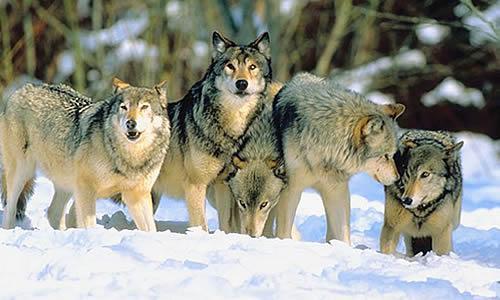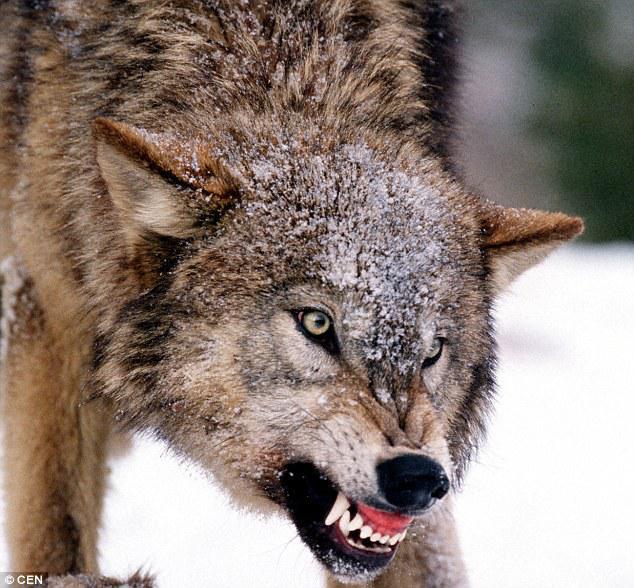The first image is the image on the left, the second image is the image on the right. Analyze the images presented: Is the assertion "The left image contains a single standing wolf in a non-snowy setting, and the right image includes two wolves with their heads side-by-side in a scene with some snow." valid? Answer yes or no. No. The first image is the image on the left, the second image is the image on the right. Evaluate the accuracy of this statement regarding the images: "There are at least three wolves walking through heavy snow.". Is it true? Answer yes or no. Yes. 